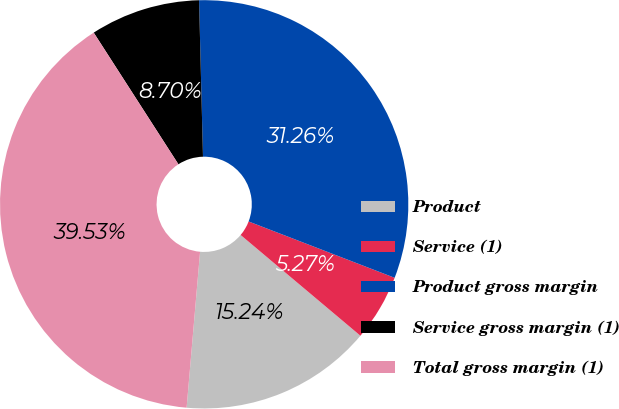<chart> <loc_0><loc_0><loc_500><loc_500><pie_chart><fcel>Product<fcel>Service (1)<fcel>Product gross margin<fcel>Service gross margin (1)<fcel>Total gross margin (1)<nl><fcel>15.24%<fcel>5.27%<fcel>31.26%<fcel>8.7%<fcel>39.53%<nl></chart> 